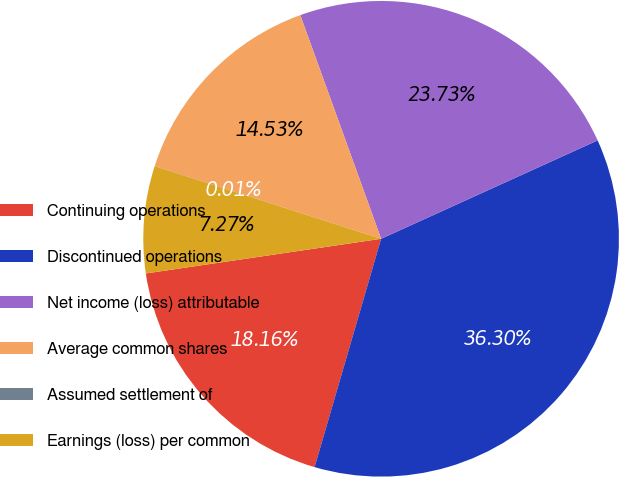Convert chart to OTSL. <chart><loc_0><loc_0><loc_500><loc_500><pie_chart><fcel>Continuing operations<fcel>Discontinued operations<fcel>Net income (loss) attributable<fcel>Average common shares<fcel>Assumed settlement of<fcel>Earnings (loss) per common<nl><fcel>18.16%<fcel>36.3%<fcel>23.73%<fcel>14.53%<fcel>0.01%<fcel>7.27%<nl></chart> 